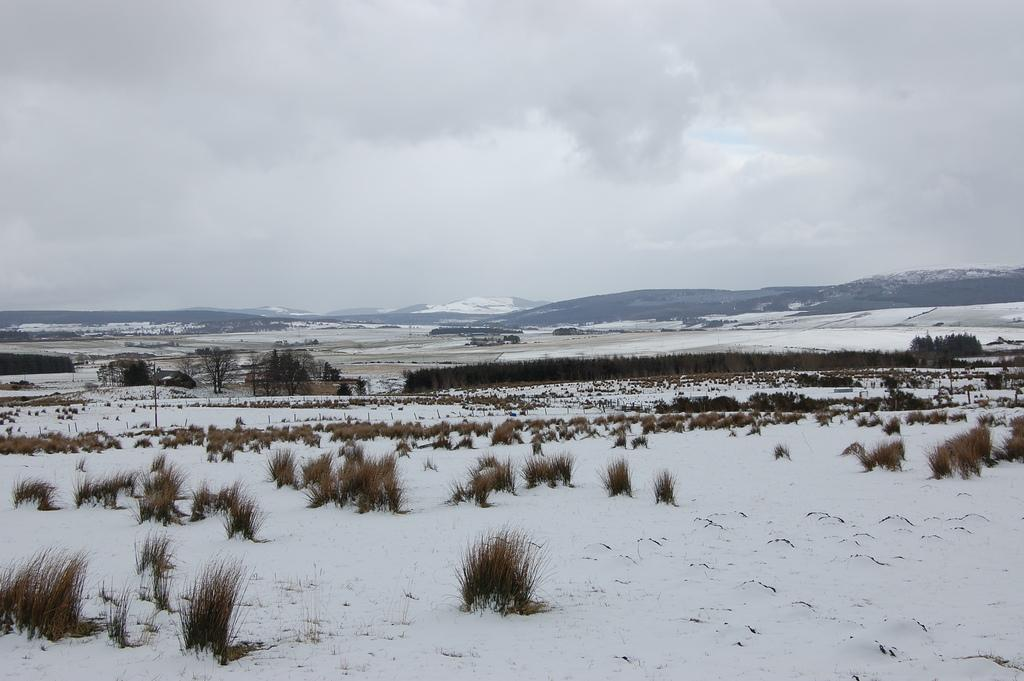What type of terrain is visible in the image? There is a land with grass in the image. What is the condition of the land in the image? The land is partially covered with snow. What can be seen in the background of the image? There are mountains visible in the background of the image. What is visible in the sky in the image? There are clouds in the sky. What type of wheel can be seen on the land in the image? There is no wheel present on the land in the image. Can you tell me how many wishes are granted in the image? There is no mention of wishes or granting wishes in the image. 